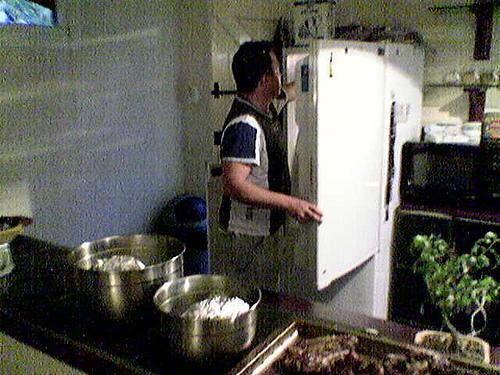What is the man touching? refrigerator 